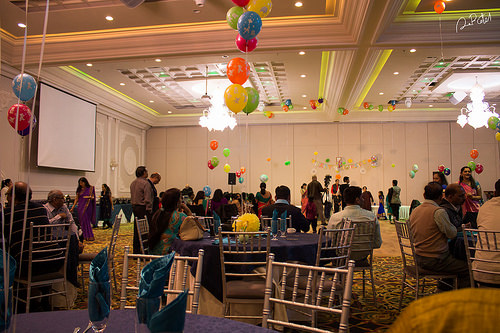<image>
Is the balloon behind the balloon? Yes. From this viewpoint, the balloon is positioned behind the balloon, with the balloon partially or fully occluding the balloon. Is there a chair behind the table? No. The chair is not behind the table. From this viewpoint, the chair appears to be positioned elsewhere in the scene. 